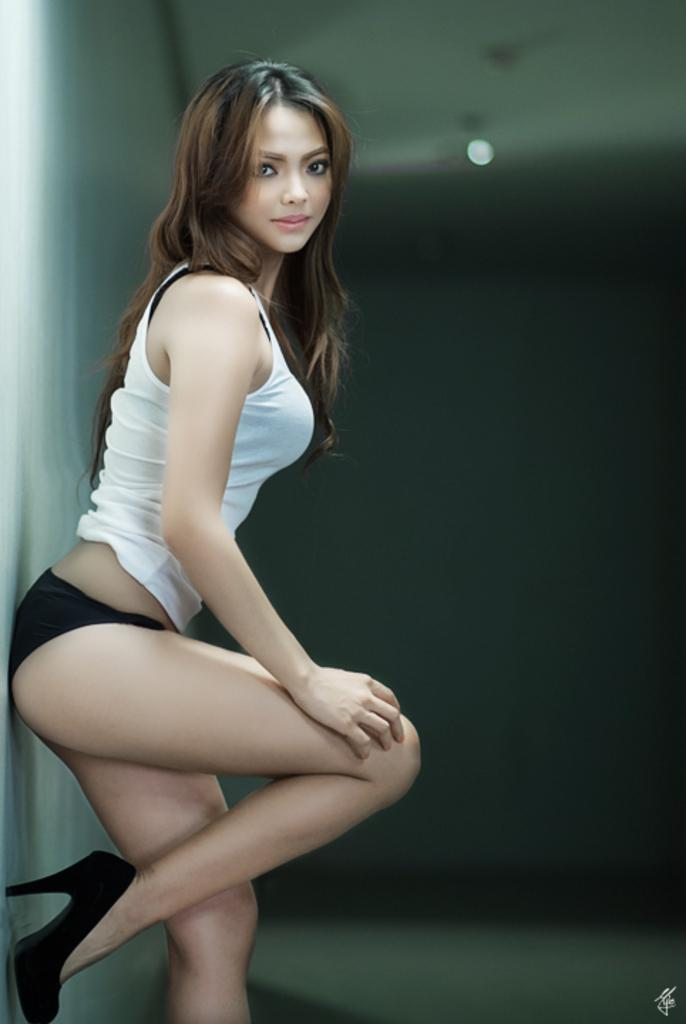Who is the main subject in the image? There is a lady in the center of the image. What can be seen in the background of the image? There is light in the background of the image. Is there any text present in the image? Yes, there is some text at the bottom of the image. Is there a ring on the lady's finger in the image? There is no mention of a ring or any jewelry in the provided facts, so we cannot determine if there is a ring on the lady's finger in the image. 